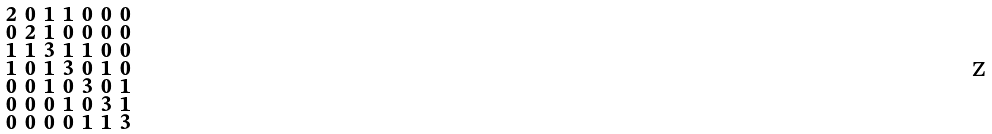Convert formula to latex. <formula><loc_0><loc_0><loc_500><loc_500>\begin{smallmatrix} 2 & 0 & 1 & 1 & 0 & 0 & 0 \\ 0 & 2 & 1 & 0 & 0 & 0 & 0 \\ 1 & 1 & 3 & 1 & 1 & 0 & 0 \\ 1 & 0 & 1 & 3 & 0 & 1 & 0 \\ 0 & 0 & 1 & 0 & 3 & 0 & 1 \\ 0 & 0 & 0 & 1 & 0 & 3 & 1 \\ 0 & 0 & 0 & 0 & 1 & 1 & 3 \end{smallmatrix}</formula> 